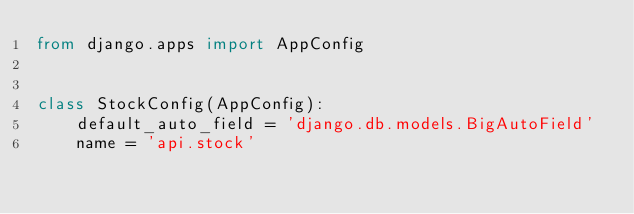<code> <loc_0><loc_0><loc_500><loc_500><_Python_>from django.apps import AppConfig


class StockConfig(AppConfig):
    default_auto_field = 'django.db.models.BigAutoField'
    name = 'api.stock'
</code> 